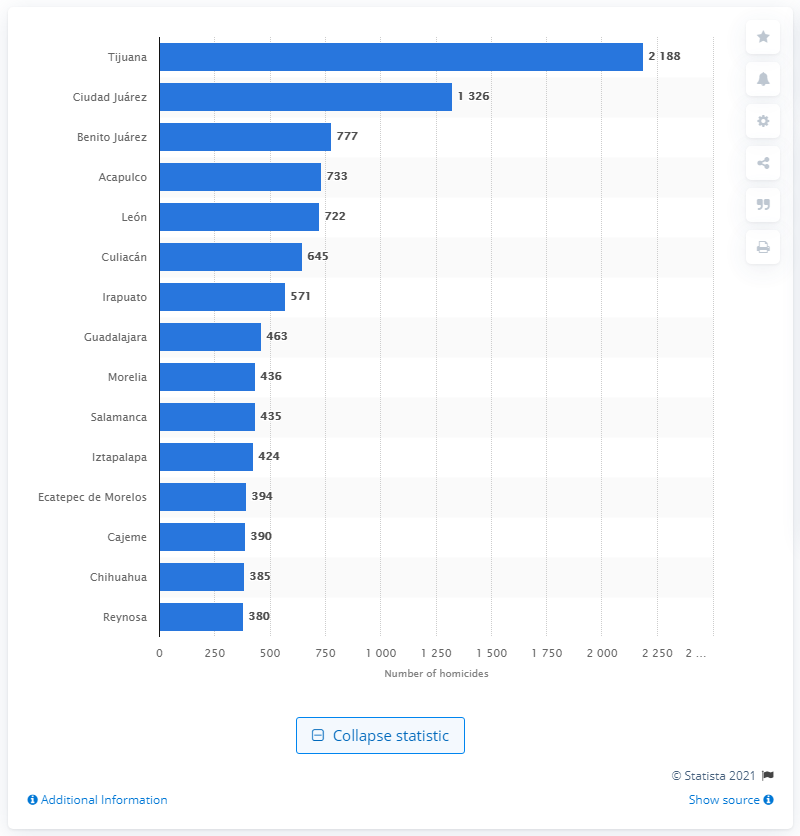Indicate a few pertinent items in this graphic. In 2019, a total of 777 homicides were recorded in Benito Juárez. 